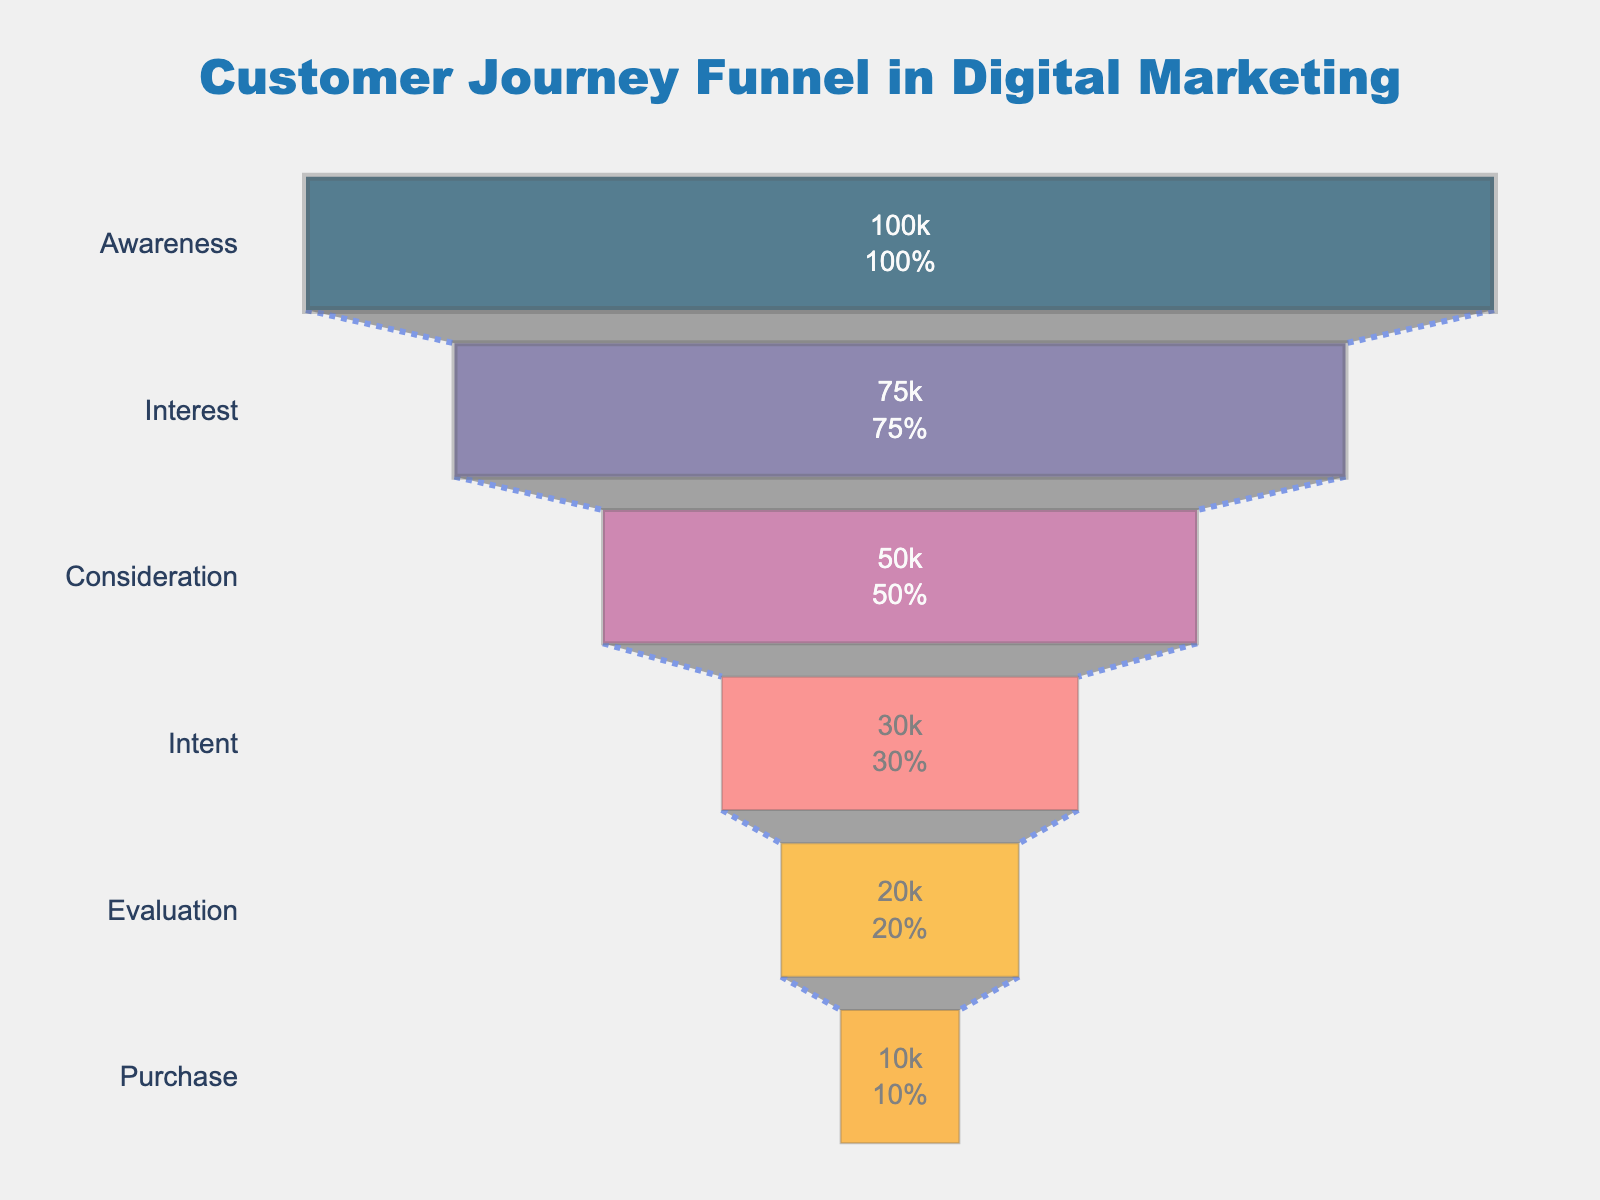What's the title of the funnel chart? The title is located at the top of the funnel chart, centered, and is in a larger and bold font.
Answer: Customer Journey Funnel in Digital Marketing What is the number of customers at the 'Interest' stage? Observe the 'Interest' stage on the funnel chart, and the number of customers is displayed inside the funnel's segment.
Answer: 75,000 Which stage has the largest drop in customer numbers? Compare the differences in customer numbers between successive stages and identify the largest decline.
Answer: Interest to Consideration What percentage of customers move from 'Intent' to 'Evaluation'? Find the number of customers at both 'Intent' (30,000) and 'Evaluation' (20,000) stages. Calculate the percentage: (20,000 / 30,000) * 100%.
Answer: 66.67% How many total customers are lost from 'Awareness' to 'Purchase'? Subtract the number of customers at 'Purchase' (10,000) from 'Awareness' (100,000) to find the total loss.
Answer: 90,000 What is the color of the 'Consideration' stage segment? The funnel chart uses different colors for each stage. The 'Consideration' stage color is third from the top.
Answer: Pink (Hex: #bc5090) Which stage represents the final step in the customer journey? The bottom-most segment of the funnel chart indicates the final customer journey stage.
Answer: Purchase What is the combined percentage of customers that drop off from 'Consideration' to 'Evaluation'? Calculate the percentage drop from 'Consideration' to 'Intent' (20,000/50,000*100%) and then from 'Intent' to 'Evaluation' (20,000/30,000*100%). Add these percentages.
Answer: 50% + 33.33% = 83.33% What is the difference in the number of customers between the 'Evaluation' and 'Purchase' stages? Subtract the number of customers at the 'Purchase' stage (10,000) from those at the 'Evaluation' stage (20,000).
Answer: 10,000 Between which stages does the highest conversion rate occur? Calculate the conversion rates between each successive stage (e.g., Interest to Consideration, Interest to Intent, etc.). The highest rate is the one with the greatest percentage of customers moving to the next stage.
Answer: Awareness to Interest 